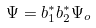Convert formula to latex. <formula><loc_0><loc_0><loc_500><loc_500>\Psi = b ^ { * } _ { 1 } b ^ { * } _ { 2 } \Psi _ { o }</formula> 